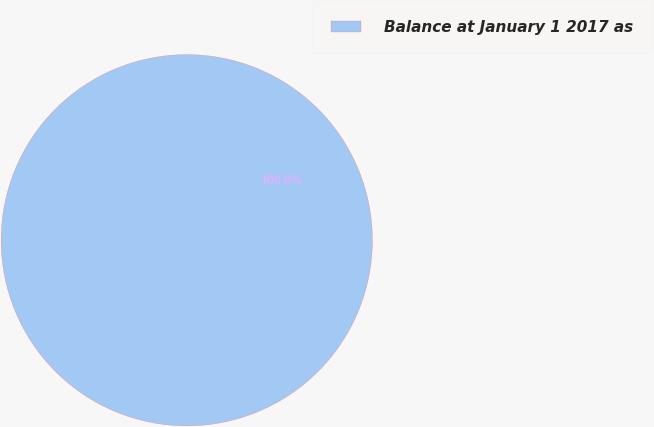<chart> <loc_0><loc_0><loc_500><loc_500><pie_chart><fcel>Balance at January 1 2017 as<nl><fcel>100.0%<nl></chart> 